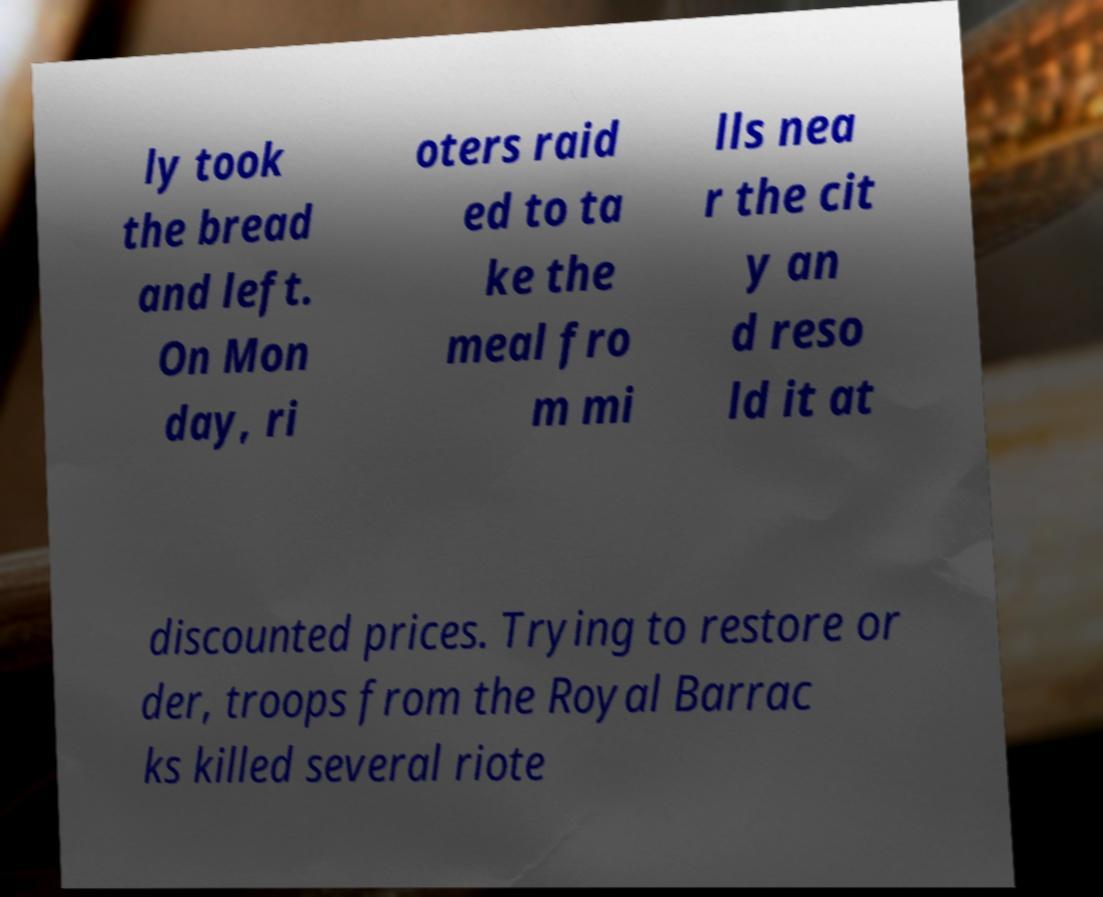There's text embedded in this image that I need extracted. Can you transcribe it verbatim? ly took the bread and left. On Mon day, ri oters raid ed to ta ke the meal fro m mi lls nea r the cit y an d reso ld it at discounted prices. Trying to restore or der, troops from the Royal Barrac ks killed several riote 